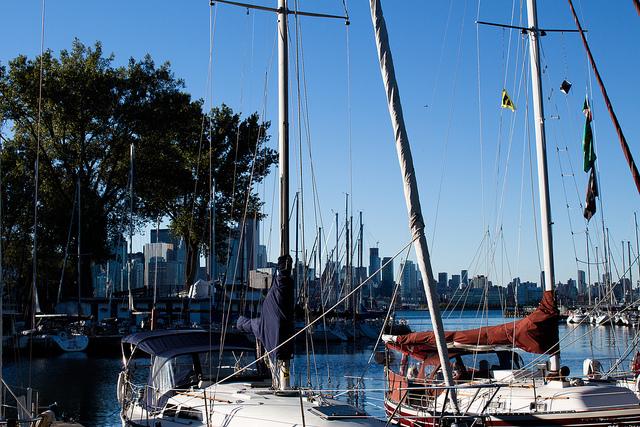Is the city on the horizon a large one?
Write a very short answer. Yes. How many of these boats have their sails unfurled?
Quick response, please. 0. Does it look like a hurricane is coming?
Give a very brief answer. No. 